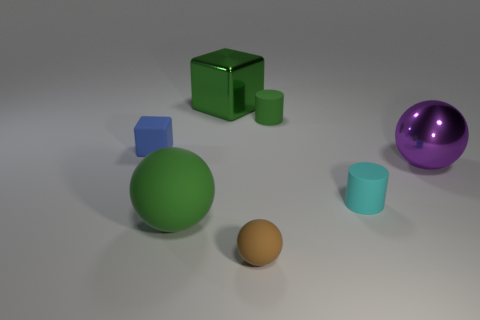What material is the other big object that is the same color as the large rubber thing?
Offer a very short reply. Metal. How many purple rubber spheres are there?
Make the answer very short. 0. Is the number of large green balls less than the number of objects?
Your answer should be compact. Yes. There is a block that is the same size as the purple metallic ball; what material is it?
Ensure brevity in your answer.  Metal. What number of things are either big blue cylinders or large objects?
Ensure brevity in your answer.  3. How many tiny objects are on the left side of the green metallic object and in front of the purple object?
Make the answer very short. 0. Is the number of tiny green rubber things that are on the left side of the metal sphere less than the number of large rubber objects?
Your answer should be compact. No. There is a metallic thing that is the same size as the shiny block; what shape is it?
Your answer should be compact. Sphere. How many other things are there of the same color as the small rubber sphere?
Provide a short and direct response. 0. Is the size of the shiny cube the same as the purple ball?
Keep it short and to the point. Yes. 